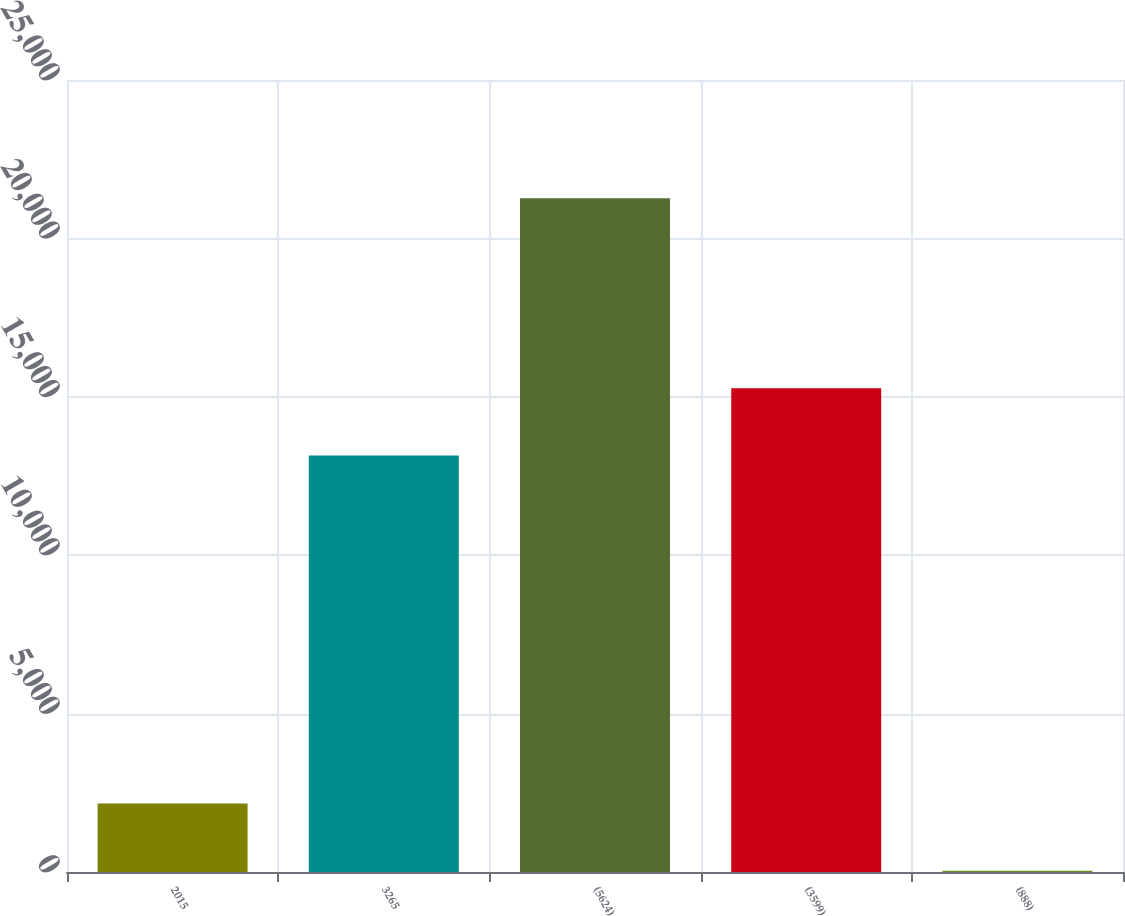Convert chart to OTSL. <chart><loc_0><loc_0><loc_500><loc_500><bar_chart><fcel>2015<fcel>3265<fcel>(5624)<fcel>(3599)<fcel>(888)<nl><fcel>2158.8<fcel>13145<fcel>21268<fcel>15268.2<fcel>35.55<nl></chart> 